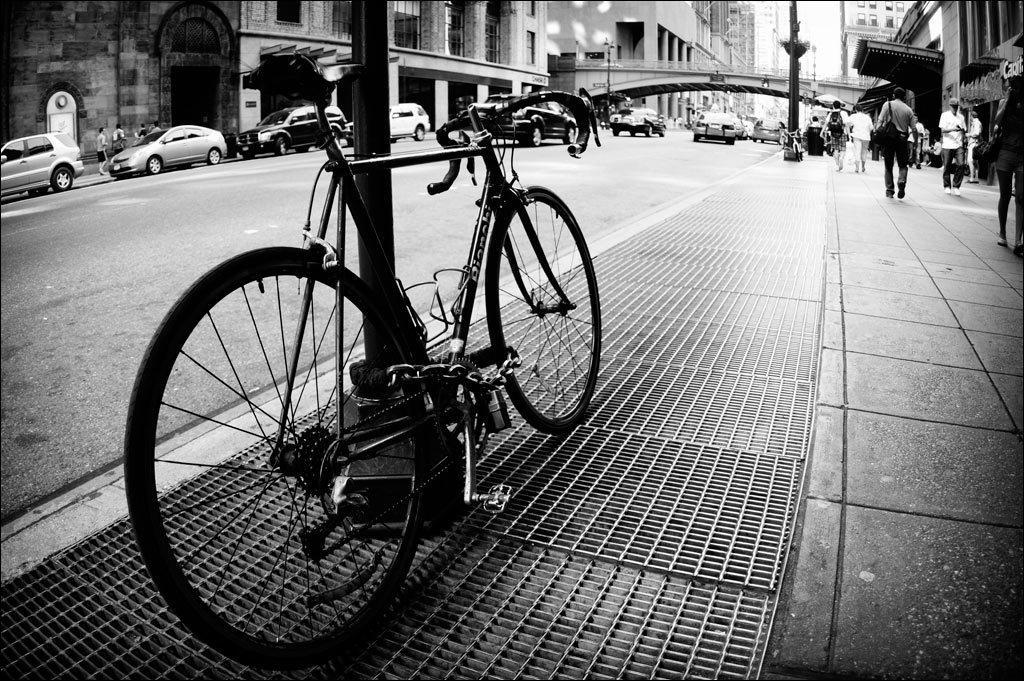How would you summarize this image in a sentence or two? This is a black and white picture. Here we can see a bicycle, cars, poles, bridge, and few people. In the background there are buildings. 